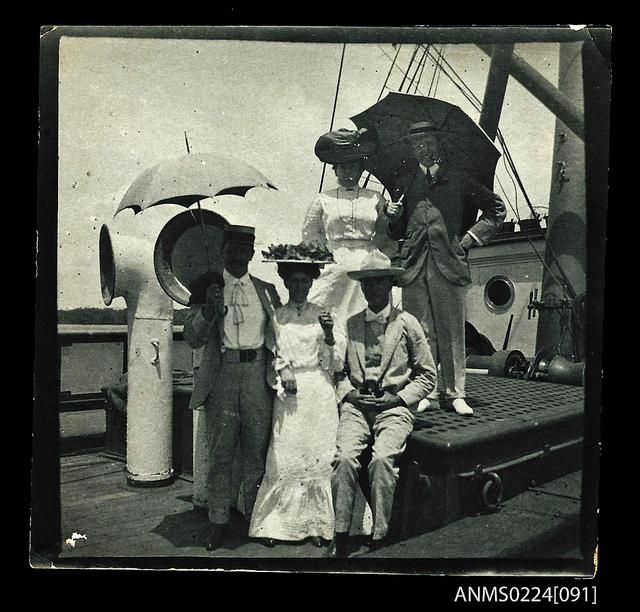Are these people on a train?
Be succinct. No. Who is holding the umbrella?
Quick response, please. Men. How many people are wearing hats?
Short answer required. 5. 